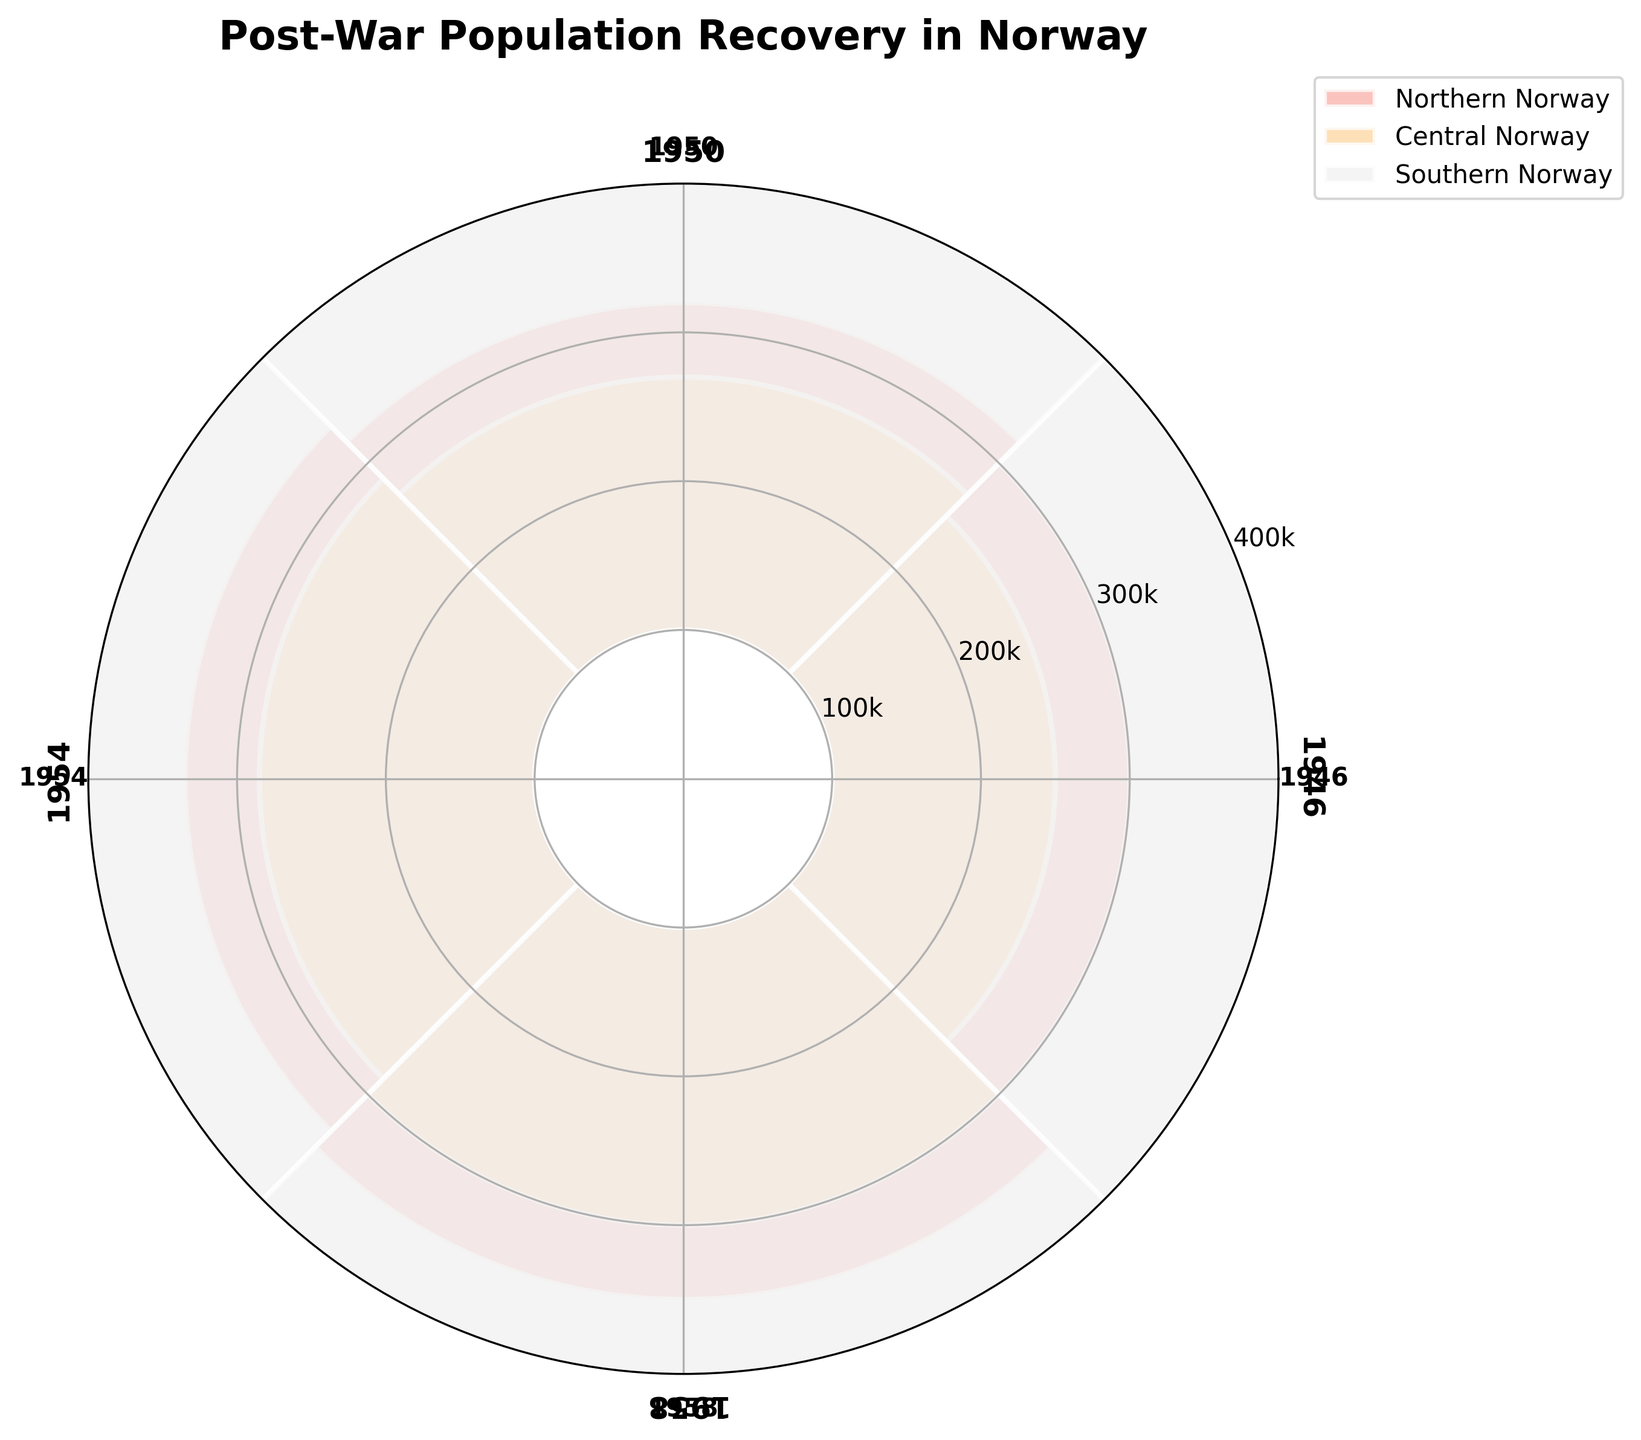What is the title of the plot? The title is located at the top of the plot in a larger and bolder font. It says "Post-War Population Recovery in Norway".
Answer: Post-War Population Recovery in Norway How many regions are being compared in the plot? The figure's legend shows the distinct regions being compared, which are represented by different colors and labeled accordingly.
Answer: Three regions Which region had the highest population in 1946? By looking at the bars corresponding to the year 1946 (located at specific angles labeled 1946 on the polar plot), observe the heights of the bars for each region. The highest bar represents Southern Norway.
Answer: Southern Norway How did the population of Northern Norway change from 1946 to 1958? Find the bars corresponding to Northern Norway and compare their heights from 1946 to 1958. Each bar's height represents the population, scaled down, so observe the increasing pattern.
Answer: Increased from 200,000 to 250,000 Which year had the smallest population gap between Northern and Central Norway? Compare the differences in the heights of corresponding bars for Northern and Central Norway across all years. Identify the year with the smallest height difference. In this case, it is observed in 1958.
Answer: 1958 Calculate the total population of all regions in 1958. Sum the populations of Northern Norway (250,000), Central Norway (200,000), and Southern Norway (350,000) from the bars labeled 1958.
Answer: 800,000 Which region showed the most consistent growth in population over the years? Examine the consistency in the increase of bar heights for each region over the years. Central Norway showed the most consistent growth with steady increases in population from 1946 to 1958.
Answer: Central Norway During which year did Southern Norway have its highest population? Locate the highest bar for Southern Norway by following the color representing it in the legend. The highest bar corresponds to the year 1958.
Answer: 1958 Compare the population growth between Northern and Southern Norway from 1946 to 1958. Calculate the differences in population for Northern Norway (i.e., 250,000 - 200,000 = 50,000) and for Southern Norway (i.e., 350,000 - 300,000 = 50,000) between 1946 and 1958. Both regions have the same growth amount.
Answer: Equal growth of 50,000 What is the mean population of Central Norway across all years? Sum the populations of Central Norway for all years (150,000 + 170,000 + 185,000 + 200,000) and divide by the number of years (4).
Answer: 176,250 